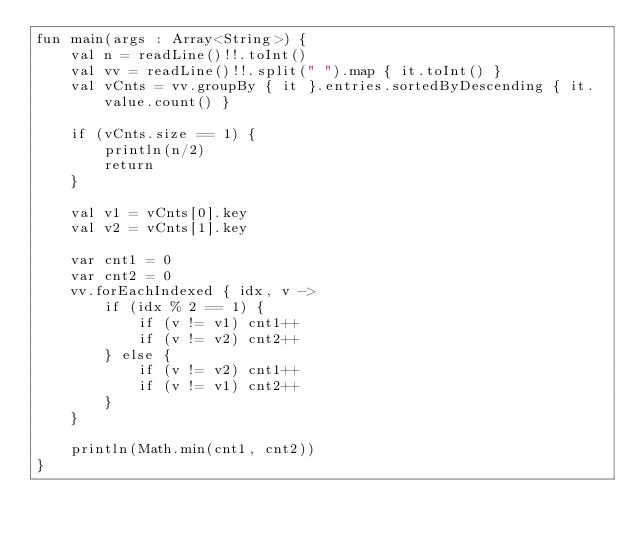<code> <loc_0><loc_0><loc_500><loc_500><_Kotlin_>fun main(args : Array<String>) {
    val n = readLine()!!.toInt()
    val vv = readLine()!!.split(" ").map { it.toInt() }
    val vCnts = vv.groupBy { it }.entries.sortedByDescending { it.value.count() }

    if (vCnts.size == 1) {
        println(n/2)
        return
    }

    val v1 = vCnts[0].key
    val v2 = vCnts[1].key

    var cnt1 = 0
    var cnt2 = 0
    vv.forEachIndexed { idx, v ->
        if (idx % 2 == 1) {
            if (v != v1) cnt1++
            if (v != v2) cnt2++
        } else {
            if (v != v2) cnt1++
            if (v != v1) cnt2++
        }
    }

    println(Math.min(cnt1, cnt2))
}</code> 